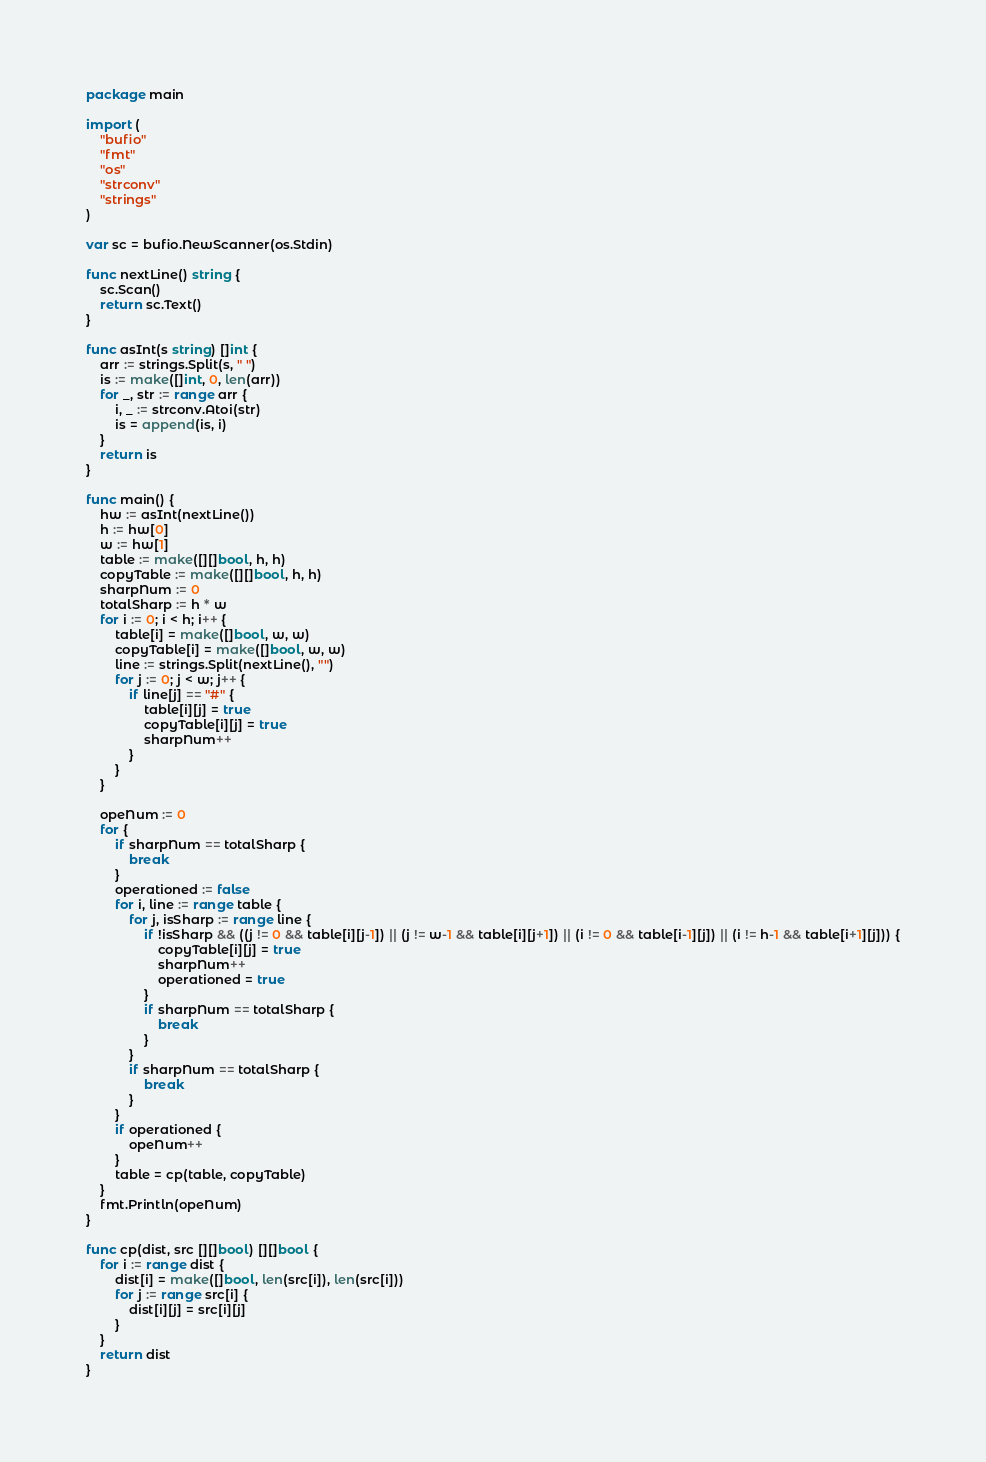Convert code to text. <code><loc_0><loc_0><loc_500><loc_500><_Go_>package main

import (
	"bufio"
	"fmt"
	"os"
	"strconv"
	"strings"
)

var sc = bufio.NewScanner(os.Stdin)

func nextLine() string {
	sc.Scan()
	return sc.Text()
}

func asInt(s string) []int {
	arr := strings.Split(s, " ")
	is := make([]int, 0, len(arr))
	for _, str := range arr {
		i, _ := strconv.Atoi(str)
		is = append(is, i)
	}
	return is
}

func main() {
	hw := asInt(nextLine())
	h := hw[0]
	w := hw[1]
	table := make([][]bool, h, h)
	copyTable := make([][]bool, h, h)
	sharpNum := 0
	totalSharp := h * w
	for i := 0; i < h; i++ {
		table[i] = make([]bool, w, w)
		copyTable[i] = make([]bool, w, w)
		line := strings.Split(nextLine(), "")
		for j := 0; j < w; j++ {
			if line[j] == "#" {
				table[i][j] = true
				copyTable[i][j] = true
				sharpNum++
			}
		}
	}

	opeNum := 0
	for {
		if sharpNum == totalSharp {
			break
		}
		operationed := false
		for i, line := range table {
			for j, isSharp := range line {
				if !isSharp && ((j != 0 && table[i][j-1]) || (j != w-1 && table[i][j+1]) || (i != 0 && table[i-1][j]) || (i != h-1 && table[i+1][j])) {
					copyTable[i][j] = true
					sharpNum++
					operationed = true
				}
				if sharpNum == totalSharp {
					break
				}
			}
			if sharpNum == totalSharp {
				break
			}
		}
		if operationed {
			opeNum++
		}
		table = cp(table, copyTable)
	}
	fmt.Println(opeNum)
}

func cp(dist, src [][]bool) [][]bool {
	for i := range dist {
		dist[i] = make([]bool, len(src[i]), len(src[i]))
		for j := range src[i] {
			dist[i][j] = src[i][j]
		}
	}
	return dist
}
</code> 